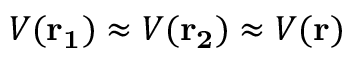<formula> <loc_0><loc_0><loc_500><loc_500>V ( r _ { 1 } ) \approx V ( r _ { 2 } ) \approx V ( r )</formula> 